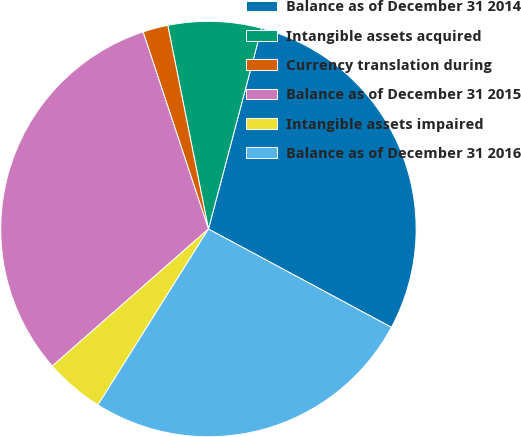<chart> <loc_0><loc_0><loc_500><loc_500><pie_chart><fcel>Balance as of December 31 2014<fcel>Intangible assets acquired<fcel>Currency translation during<fcel>Balance as of December 31 2015<fcel>Intangible assets impaired<fcel>Balance as of December 31 2016<nl><fcel>28.73%<fcel>7.25%<fcel>1.96%<fcel>31.37%<fcel>4.61%<fcel>26.08%<nl></chart> 